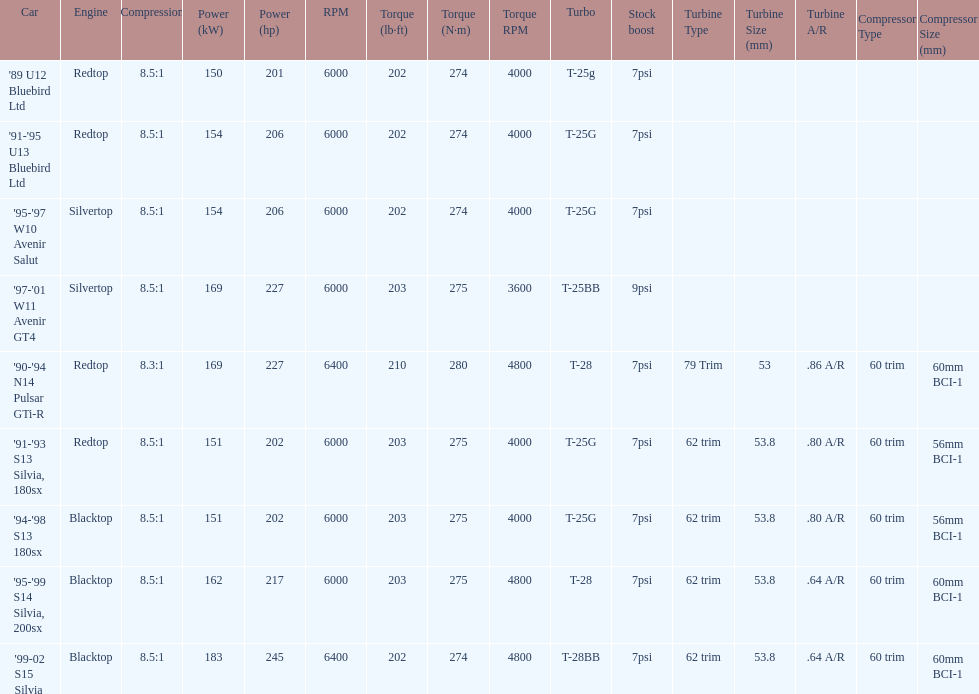Which engine(s) has the least amount of power? Redtop. 